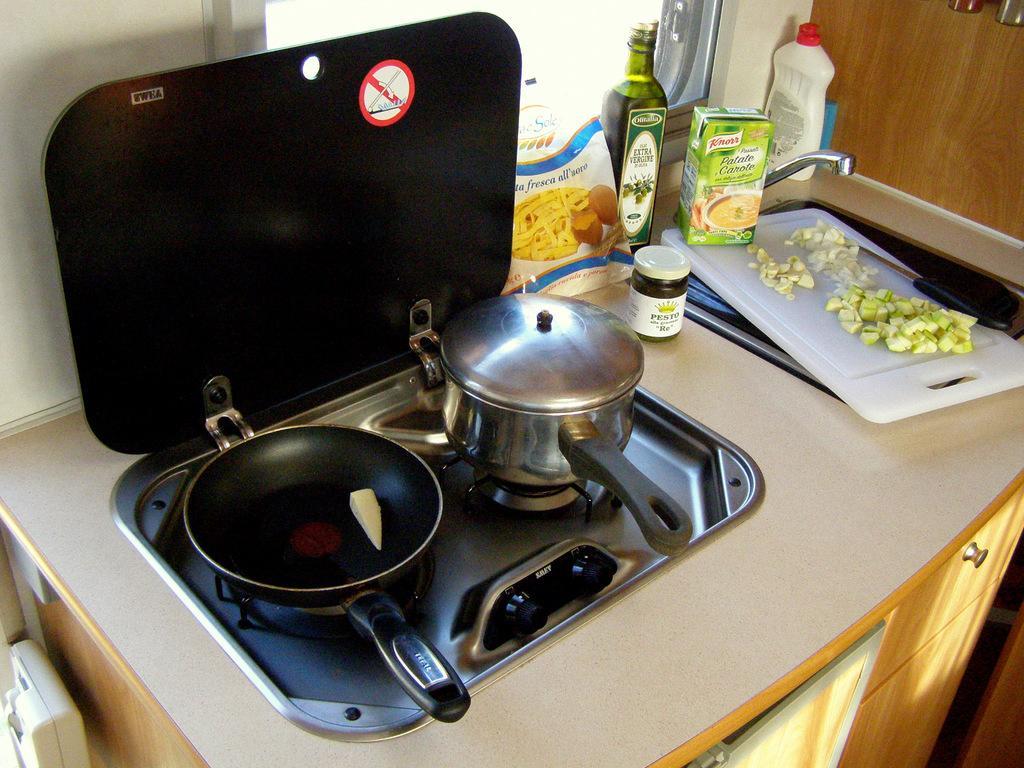How would you summarize this image in a sentence or two? In this image, we can see the stove cupboards, bottles, sink with tap, container, packet, box, some objects and chopping board with edible things and knife. In the background, there is a window and wall. On the stove, we can see a cooking pan with food and a cooking pot with a lid. 